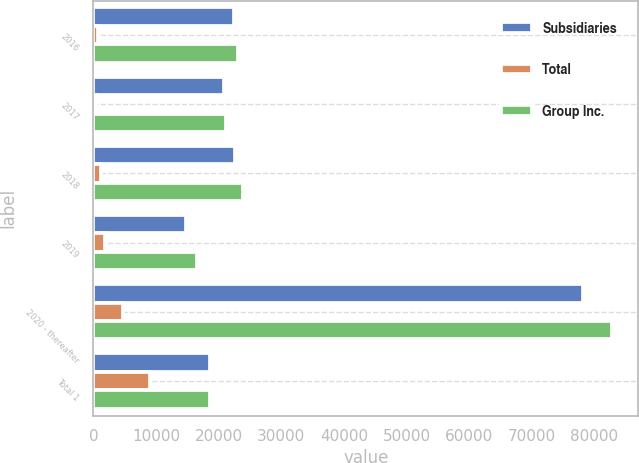Convert chart to OTSL. <chart><loc_0><loc_0><loc_500><loc_500><stacked_bar_chart><ecel><fcel>2016<fcel>2017<fcel>2018<fcel>2019<fcel>2020 - thereafter<fcel>Total 1<nl><fcel>Subsidiaries<fcel>22368<fcel>20818<fcel>22564<fcel>14718<fcel>78098<fcel>18663.5<nl><fcel>Total<fcel>789<fcel>367<fcel>1272<fcel>1791<fcel>4786<fcel>9005<nl><fcel>Group Inc.<fcel>23157<fcel>21185<fcel>23836<fcel>16509<fcel>82884<fcel>18663.5<nl></chart> 